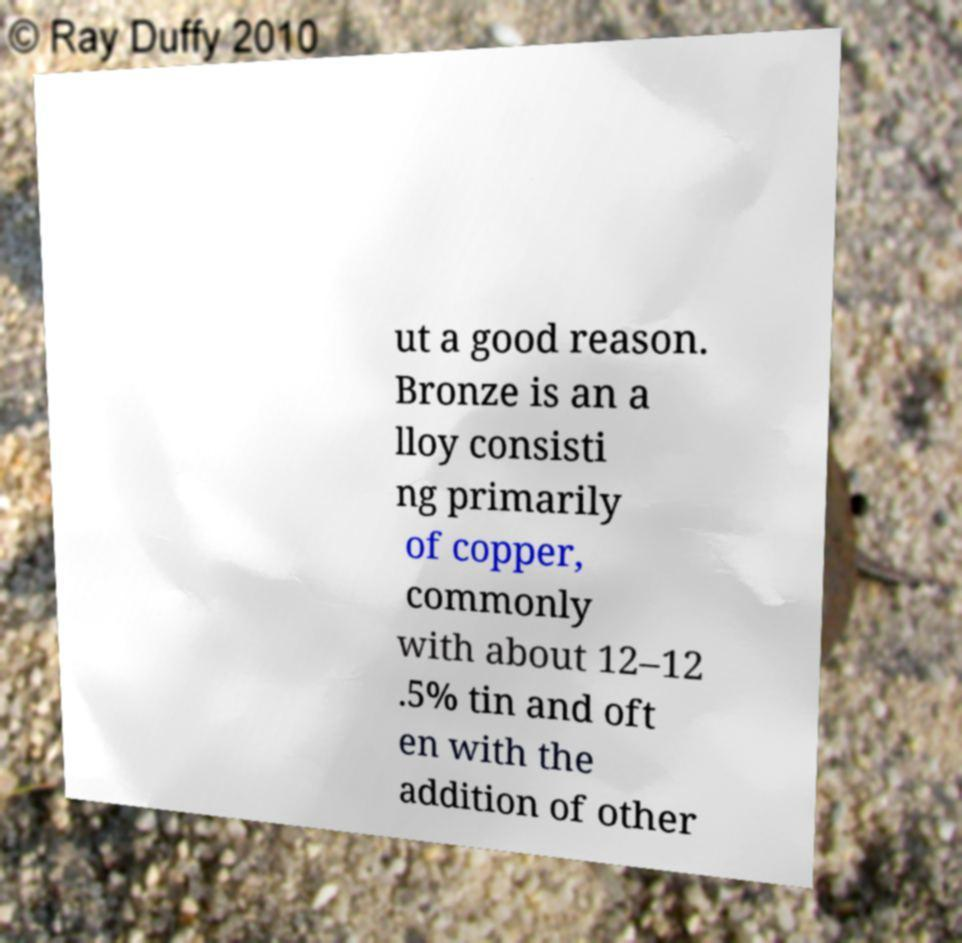Can you read and provide the text displayed in the image?This photo seems to have some interesting text. Can you extract and type it out for me? ut a good reason. Bronze is an a lloy consisti ng primarily of copper, commonly with about 12–12 .5% tin and oft en with the addition of other 